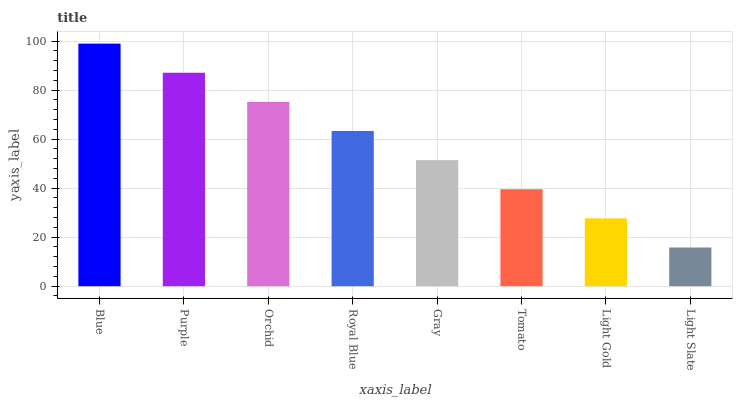Is Purple the minimum?
Answer yes or no. No. Is Purple the maximum?
Answer yes or no. No. Is Blue greater than Purple?
Answer yes or no. Yes. Is Purple less than Blue?
Answer yes or no. Yes. Is Purple greater than Blue?
Answer yes or no. No. Is Blue less than Purple?
Answer yes or no. No. Is Royal Blue the high median?
Answer yes or no. Yes. Is Gray the low median?
Answer yes or no. Yes. Is Tomato the high median?
Answer yes or no. No. Is Tomato the low median?
Answer yes or no. No. 